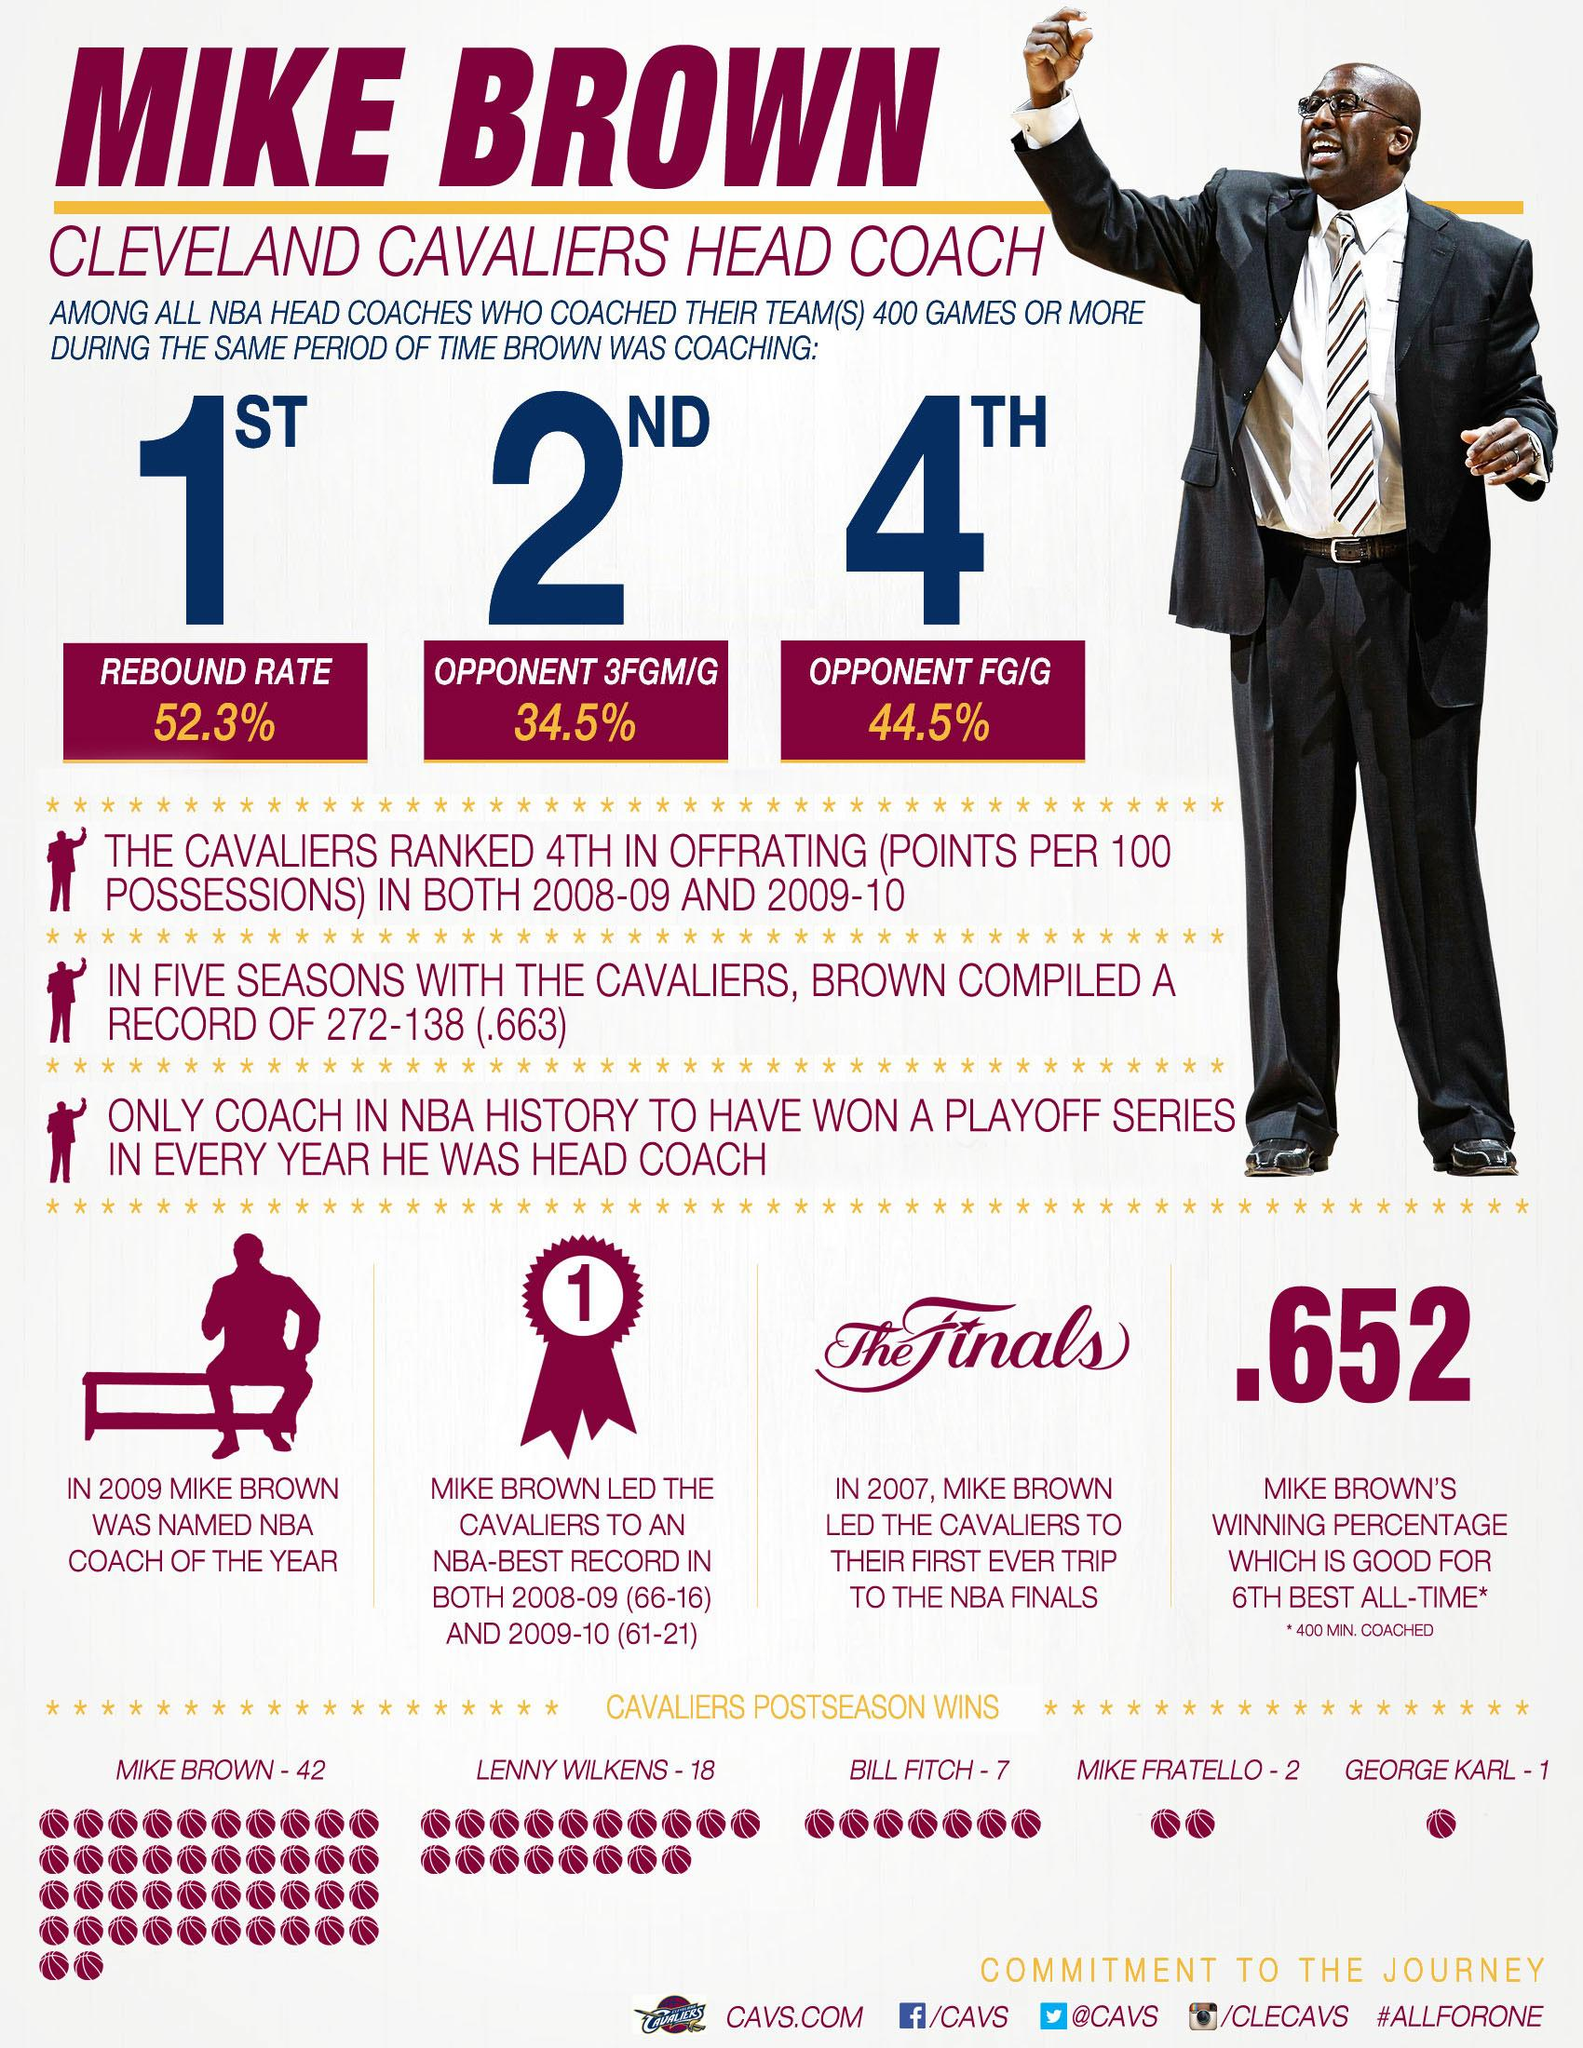Give some essential details in this illustration. Mike Brown was named the NBA coach of the year in 2009. In the year 2007, Mike Brown led the Cleveland Cavaliers to their first ever appearance in the NBA Finals. 